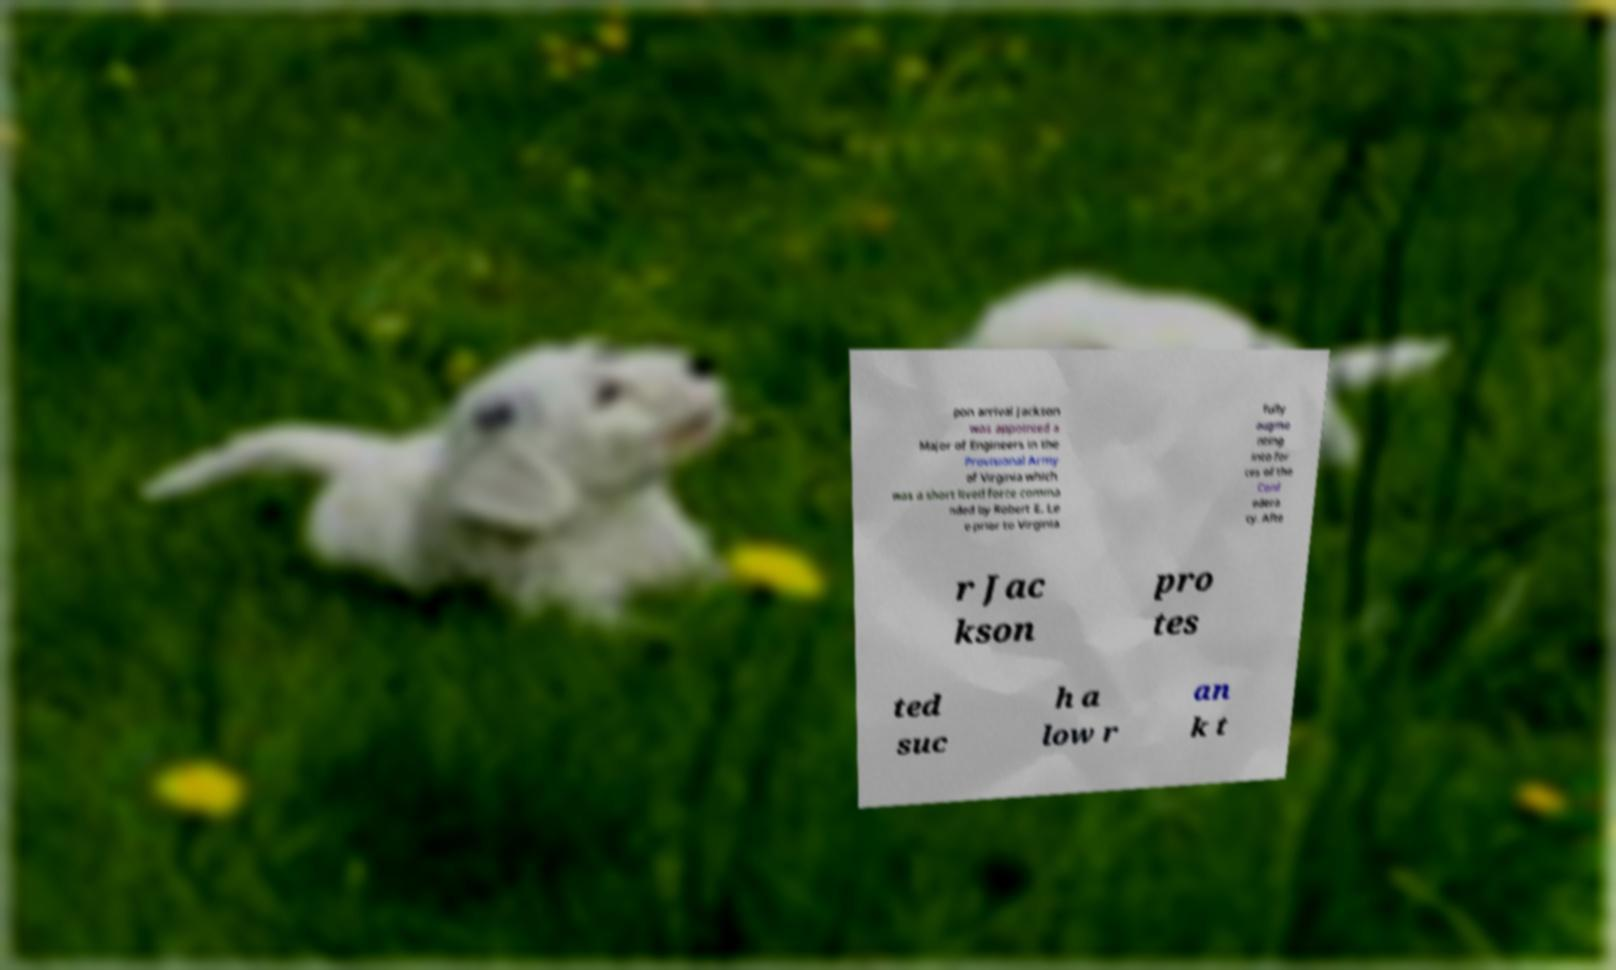For documentation purposes, I need the text within this image transcribed. Could you provide that? pon arrival Jackson was appointed a Major of Engineers in the Provisional Army of Virginia which was a short lived force comma nded by Robert E. Le e prior to Virginia fully augme nting into for ces of the Conf edera cy. Afte r Jac kson pro tes ted suc h a low r an k t 